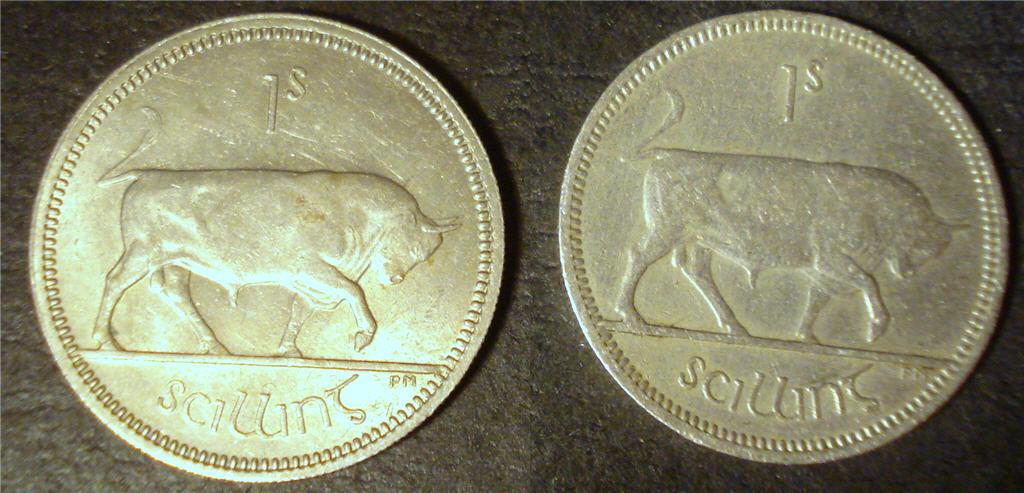<image>
Offer a succinct explanation of the picture presented. Two coins next each other with a buffalo on them and a 1s on the top. 